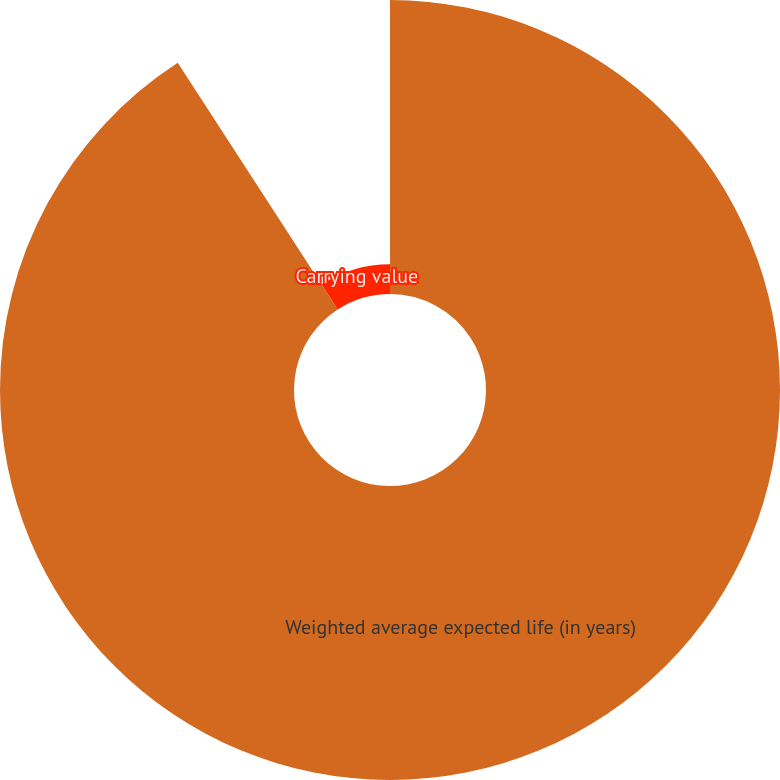<chart> <loc_0><loc_0><loc_500><loc_500><pie_chart><fcel>Weighted average expected life (in years)<fcel>Carrying value<nl><fcel>90.84%<fcel>9.16%<nl></chart> 